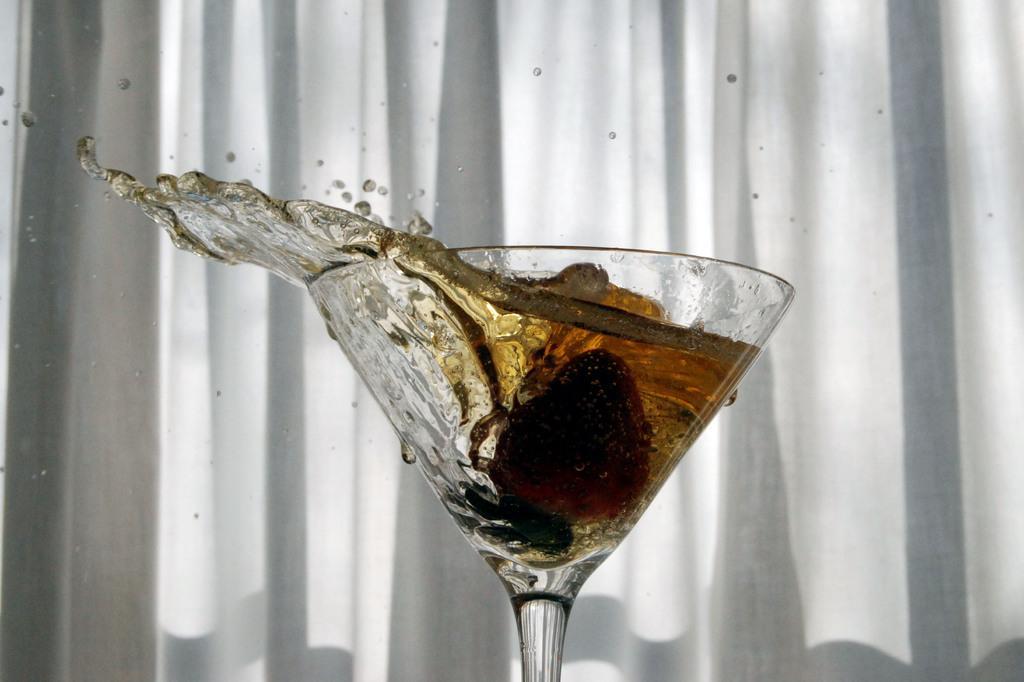How would you summarize this image in a sentence or two? In this image there is a wine glass, in that glass there is liquid, in the background there is white curtain. 